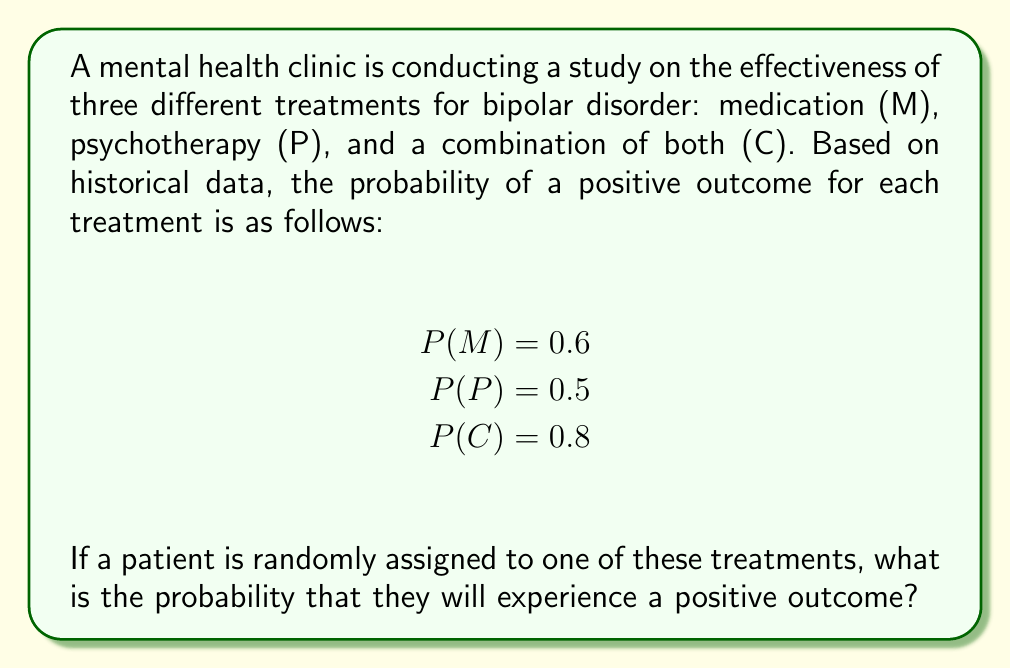Solve this math problem. To solve this problem, we need to use the law of total probability. The probability of a positive outcome is the sum of the probabilities of a positive outcome for each treatment, multiplied by the probability of being assigned to that treatment.

Let's break it down step-by-step:

1. First, we need to determine the probability of being assigned to each treatment. Since the assignment is random, we can assume that each treatment has an equal probability of being chosen:

   $P(\text{assigned to M}) = P(\text{assigned to P}) = P(\text{assigned to C}) = \frac{1}{3}$

2. Now, we can apply the law of total probability:

   $$\begin{align*}
   P(\text{positive outcome}) &= P(M) \cdot P(\text{assigned to M}) + P(P) \cdot P(\text{assigned to P}) + P(C) \cdot P(\text{assigned to C}) \\[2ex]
   &= 0.6 \cdot \frac{1}{3} + 0.5 \cdot \frac{1}{3} + 0.8 \cdot \frac{1}{3} \\[2ex]
   &= \frac{0.6}{3} + \frac{0.5}{3} + \frac{0.8}{3} \\[2ex]
   &= \frac{0.6 + 0.5 + 0.8}{3} \\[2ex]
   &= \frac{1.9}{3} \\[2ex]
   &= 0.6333...
   \end{align*}$$

3. Therefore, the probability of a positive outcome for a randomly assigned patient is approximately 0.6333 or 63.33%.
Answer: $\frac{19}{30}$ or approximately $0.6333$ (63.33%) 